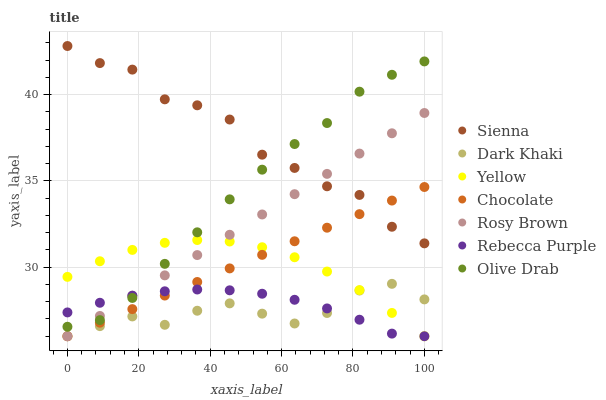Does Dark Khaki have the minimum area under the curve?
Answer yes or no. Yes. Does Sienna have the maximum area under the curve?
Answer yes or no. Yes. Does Rosy Brown have the minimum area under the curve?
Answer yes or no. No. Does Rosy Brown have the maximum area under the curve?
Answer yes or no. No. Is Chocolate the smoothest?
Answer yes or no. Yes. Is Sienna the roughest?
Answer yes or no. Yes. Is Rosy Brown the smoothest?
Answer yes or no. No. Is Rosy Brown the roughest?
Answer yes or no. No. Does Dark Khaki have the lowest value?
Answer yes or no. Yes. Does Sienna have the lowest value?
Answer yes or no. No. Does Sienna have the highest value?
Answer yes or no. Yes. Does Rosy Brown have the highest value?
Answer yes or no. No. Is Chocolate less than Olive Drab?
Answer yes or no. Yes. Is Sienna greater than Yellow?
Answer yes or no. Yes. Does Rebecca Purple intersect Dark Khaki?
Answer yes or no. Yes. Is Rebecca Purple less than Dark Khaki?
Answer yes or no. No. Is Rebecca Purple greater than Dark Khaki?
Answer yes or no. No. Does Chocolate intersect Olive Drab?
Answer yes or no. No. 